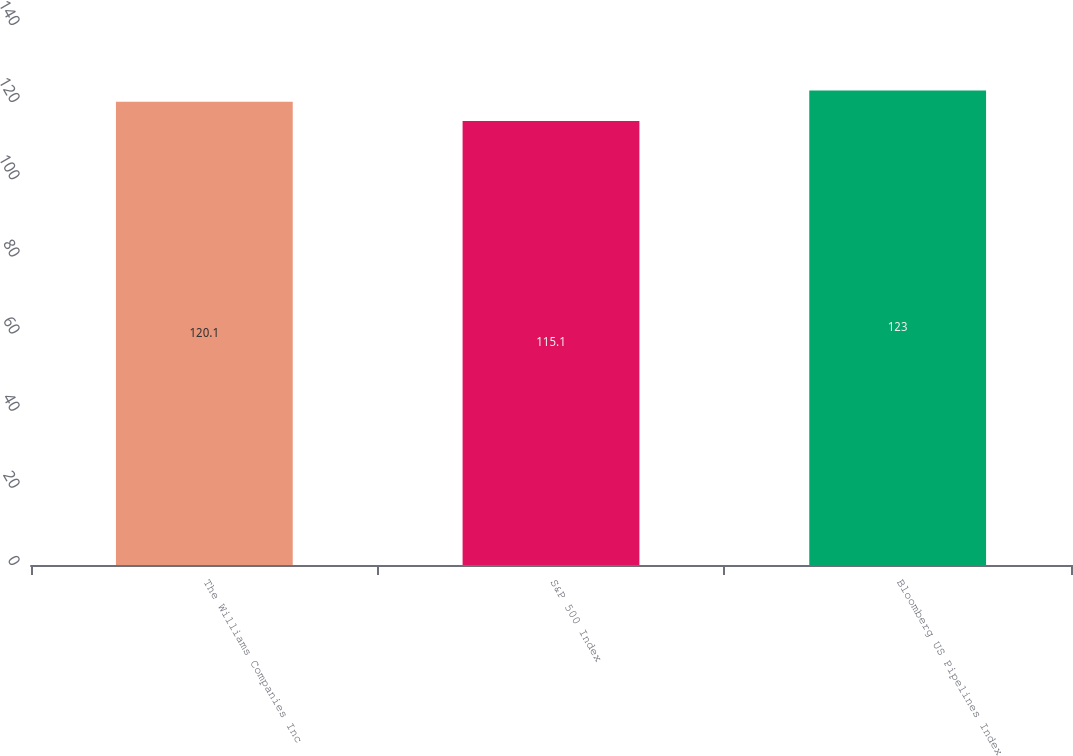<chart> <loc_0><loc_0><loc_500><loc_500><bar_chart><fcel>The Williams Companies Inc<fcel>S&P 500 Index<fcel>Bloomberg US Pipelines Index<nl><fcel>120.1<fcel>115.1<fcel>123<nl></chart> 